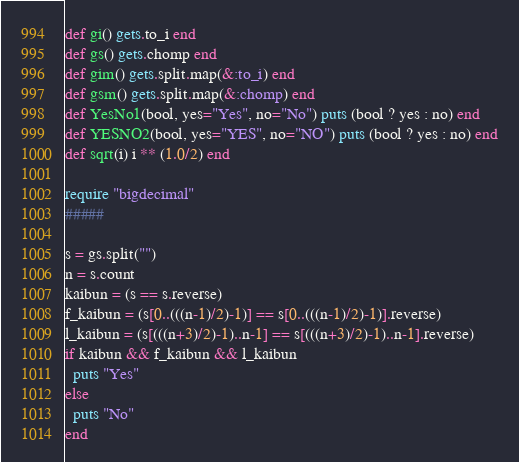<code> <loc_0><loc_0><loc_500><loc_500><_Ruby_>def gi() gets.to_i end
def gs() gets.chomp end
def gim() gets.split.map(&:to_i) end
def gsm() gets.split.map(&:chomp) end
def YesNo1(bool, yes="Yes", no="No") puts (bool ? yes : no) end
def YESNO2(bool, yes="YES", no="NO") puts (bool ? yes : no) end
def sqrt(i) i ** (1.0/2) end

require "bigdecimal"
#####

s = gs.split("")
n = s.count
kaibun = (s == s.reverse)
f_kaibun = (s[0..(((n-1)/2)-1)] == s[0..(((n-1)/2)-1)].reverse)
l_kaibun = (s[(((n+3)/2)-1)..n-1] == s[(((n+3)/2)-1)..n-1].reverse)
if kaibun && f_kaibun && l_kaibun
  puts "Yes"
else
  puts "No"
end</code> 